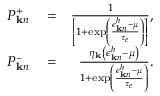<formula> <loc_0><loc_0><loc_500><loc_500>\begin{array} { r l r } { P _ { { k } n } ^ { + } } & = } & { \frac { 1 } { \left [ 1 + \exp \left ( \frac { \epsilon _ { { k } n } ^ { h } - \mu } { \tau _ { e } } \right ) \right ] } , } \\ { P _ { { k } n } ^ { - } } & = } & { \frac { \eta _ { k } \left ( \epsilon _ { { k } n } ^ { h } - \mu \right ) } { 1 + \exp \left ( \frac { \epsilon _ { { k } n } ^ { h } - \mu } { \tau _ { e } } \right ) } . } \end{array}</formula> 